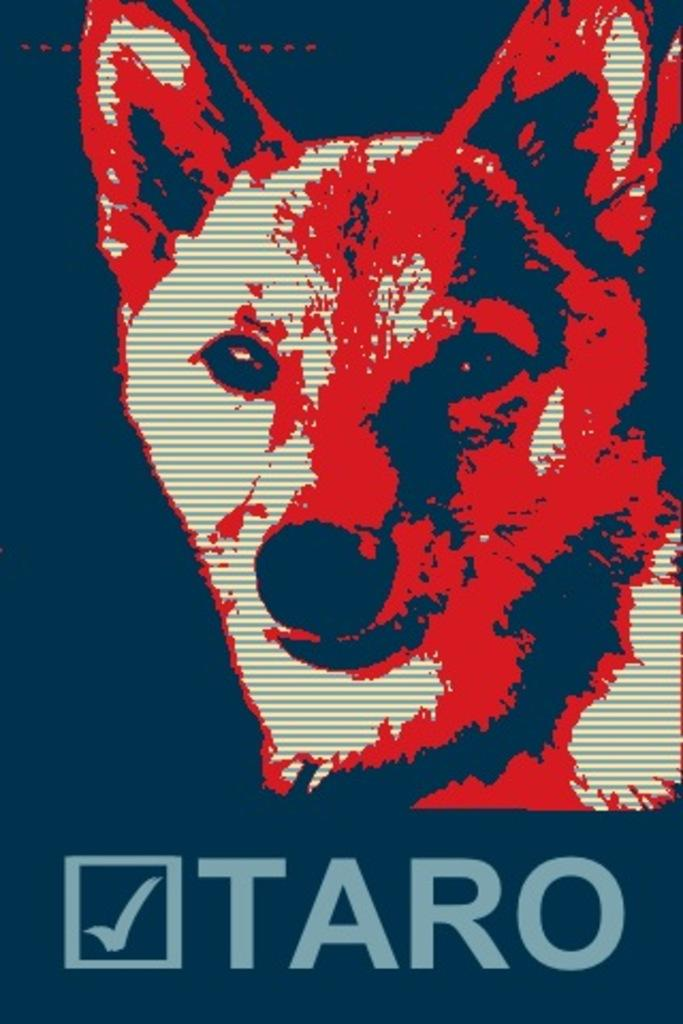What type of animal is present in the image? There is a dog in the image. What type of toothbrush is the dog using in the image? There is no toothbrush present in the image, as it only features a dog. 